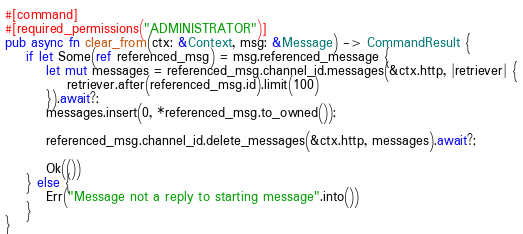Convert code to text. <code><loc_0><loc_0><loc_500><loc_500><_Rust_>
#[command]
#[required_permissions("ADMINISTRATOR")]
pub async fn clear_from(ctx: &Context, msg: &Message) -> CommandResult {
    if let Some(ref referenced_msg) = msg.referenced_message {
        let mut messages = referenced_msg.channel_id.messages(&ctx.http, |retriever| {
            retriever.after(referenced_msg.id).limit(100)
        }).await?;
        messages.insert(0, *referenced_msg.to_owned());

        referenced_msg.channel_id.delete_messages(&ctx.http, messages).await?;

        Ok(())
    } else {
        Err("Message not a reply to starting message".into())
    }
}
</code> 